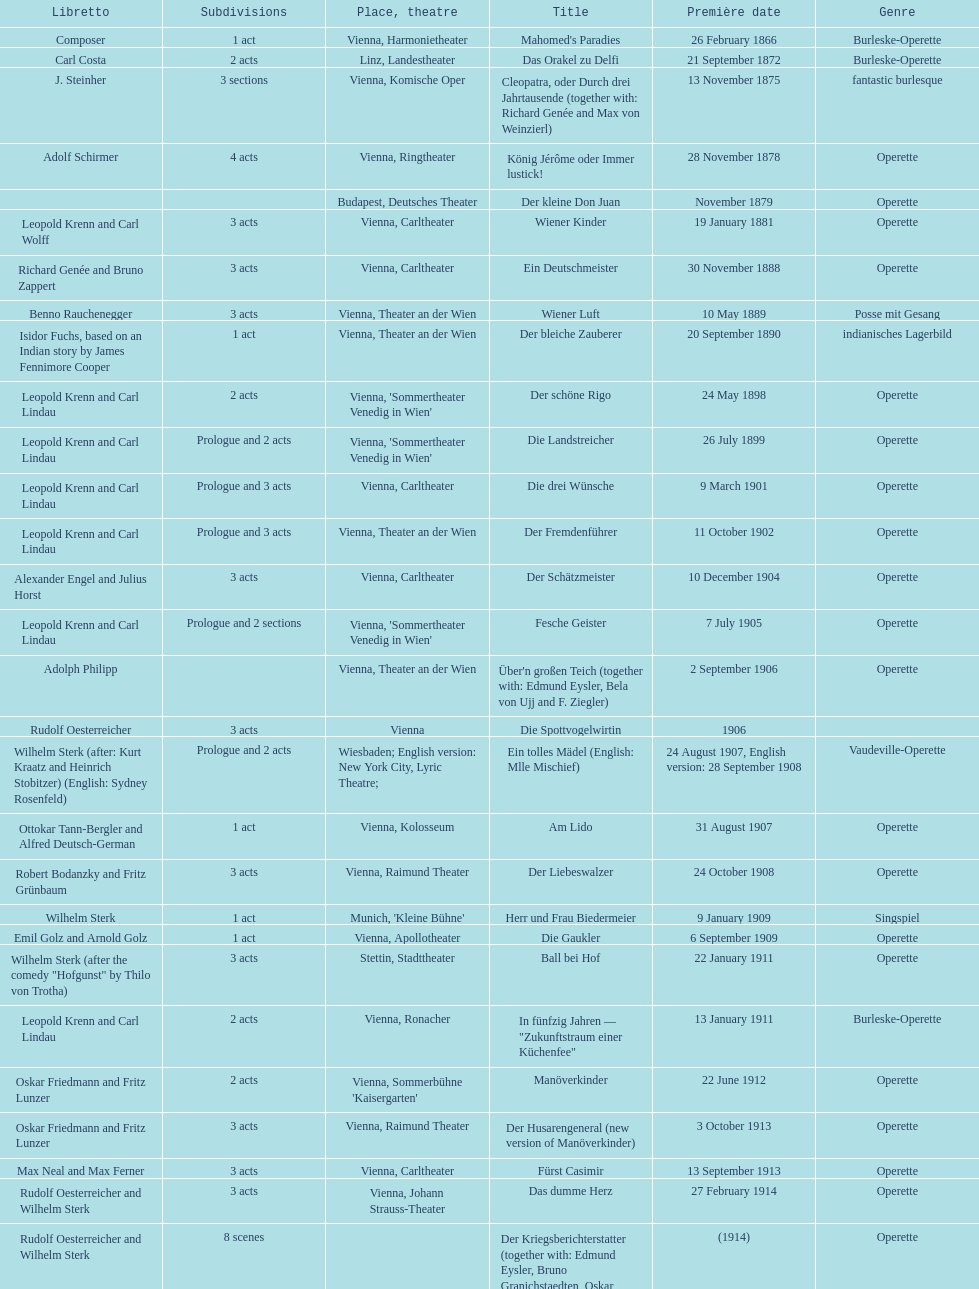What are the number of titles that premiered in the month of september? 4. 